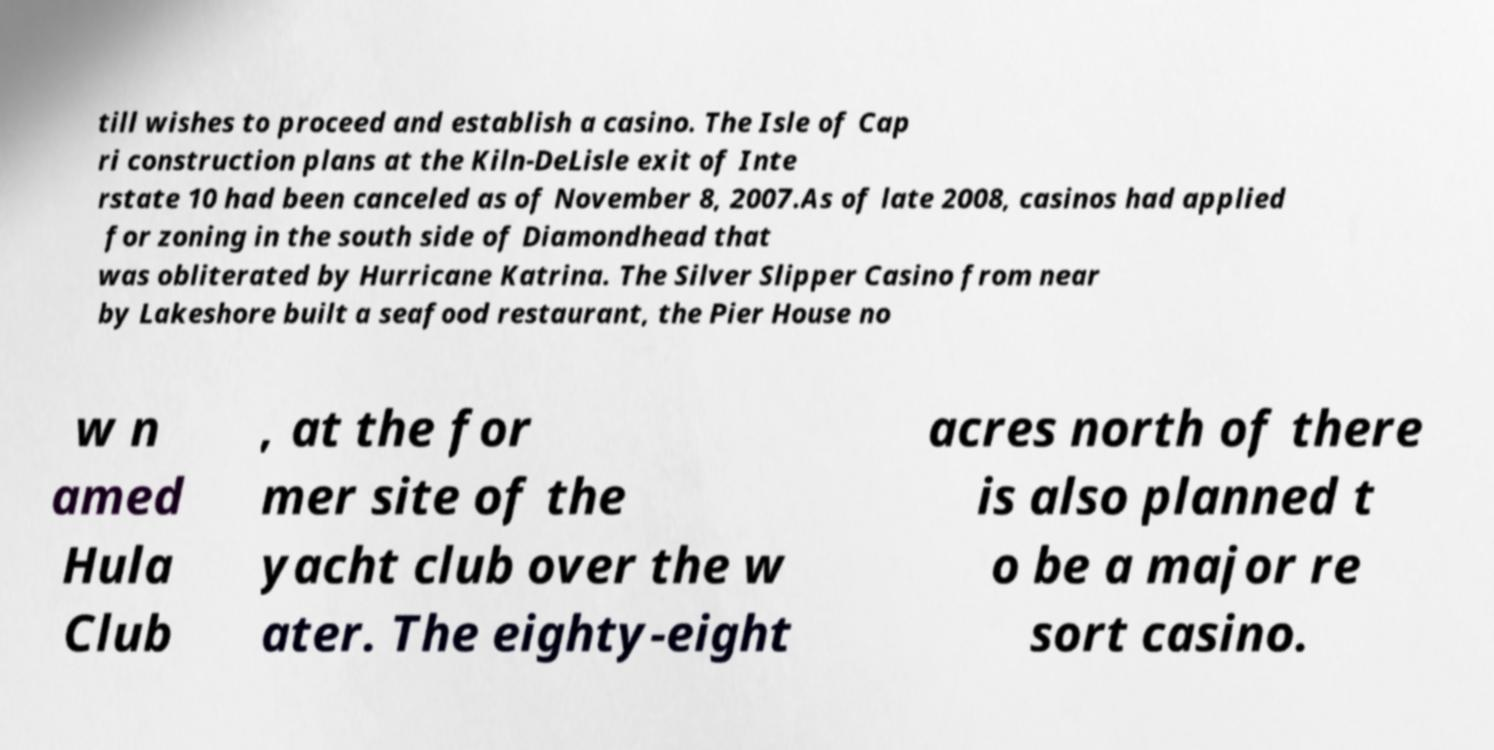There's text embedded in this image that I need extracted. Can you transcribe it verbatim? till wishes to proceed and establish a casino. The Isle of Cap ri construction plans at the Kiln-DeLisle exit of Inte rstate 10 had been canceled as of November 8, 2007.As of late 2008, casinos had applied for zoning in the south side of Diamondhead that was obliterated by Hurricane Katrina. The Silver Slipper Casino from near by Lakeshore built a seafood restaurant, the Pier House no w n amed Hula Club , at the for mer site of the yacht club over the w ater. The eighty-eight acres north of there is also planned t o be a major re sort casino. 